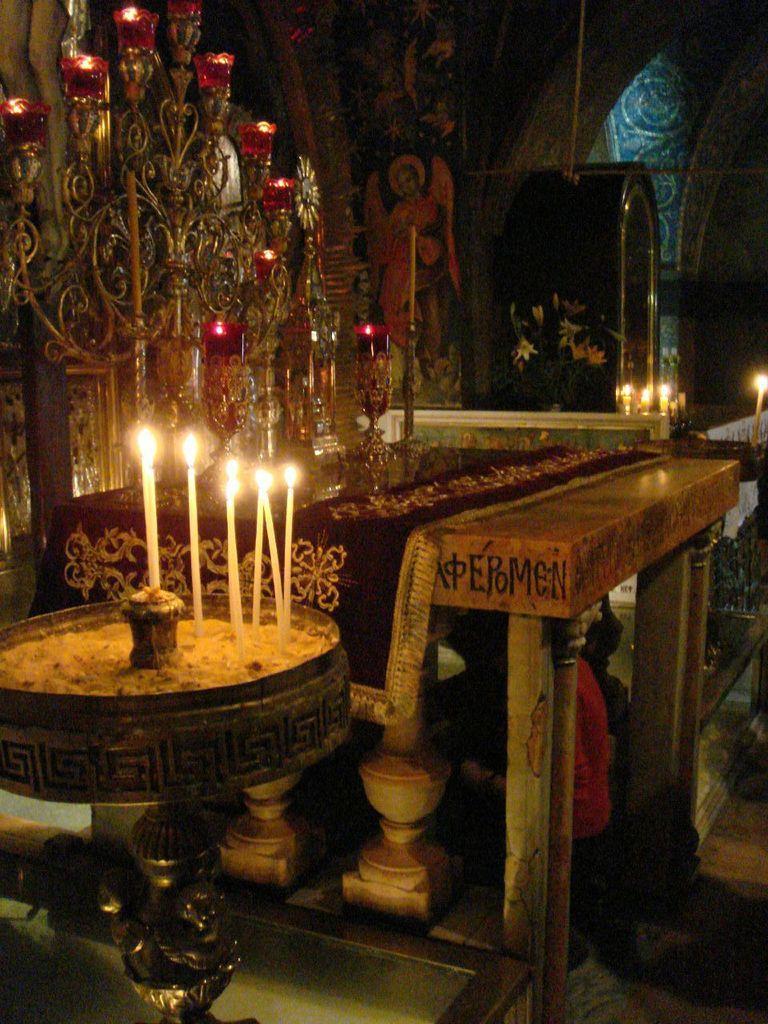How would you summarize this image in a sentence or two? In this picture we can see candles on stands and cloth on the table. In the background of the image we can see painting on the wall, candles and objects. 